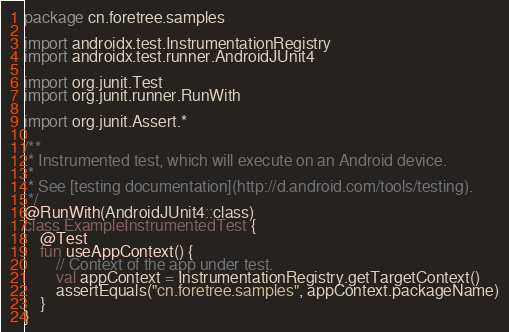<code> <loc_0><loc_0><loc_500><loc_500><_Kotlin_>package cn.foretree.samples

import androidx.test.InstrumentationRegistry
import androidx.test.runner.AndroidJUnit4

import org.junit.Test
import org.junit.runner.RunWith

import org.junit.Assert.*

/**
 * Instrumented test, which will execute on an Android device.
 *
 * See [testing documentation](http://d.android.com/tools/testing).
 */
@RunWith(AndroidJUnit4::class)
class ExampleInstrumentedTest {
    @Test
    fun useAppContext() {
        // Context of the app under test.
        val appContext = InstrumentationRegistry.getTargetContext()
        assertEquals("cn.foretree.samples", appContext.packageName)
    }
}
</code> 